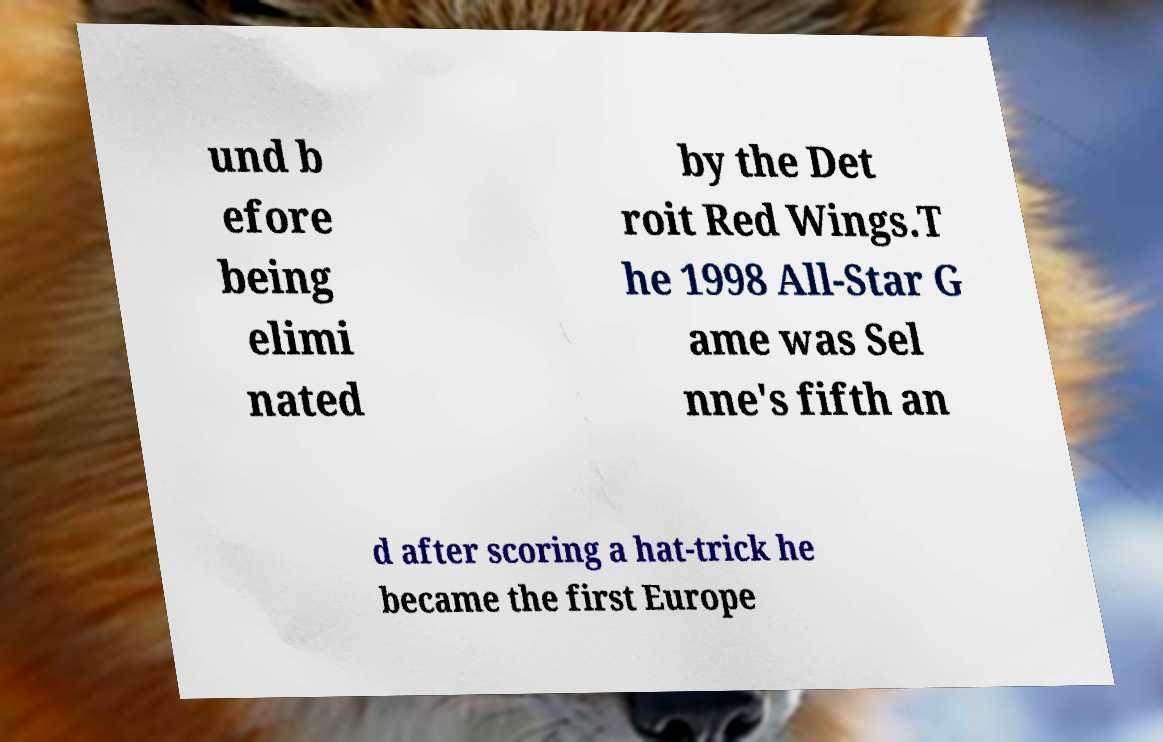Please identify and transcribe the text found in this image. und b efore being elimi nated by the Det roit Red Wings.T he 1998 All-Star G ame was Sel nne's fifth an d after scoring a hat-trick he became the first Europe 